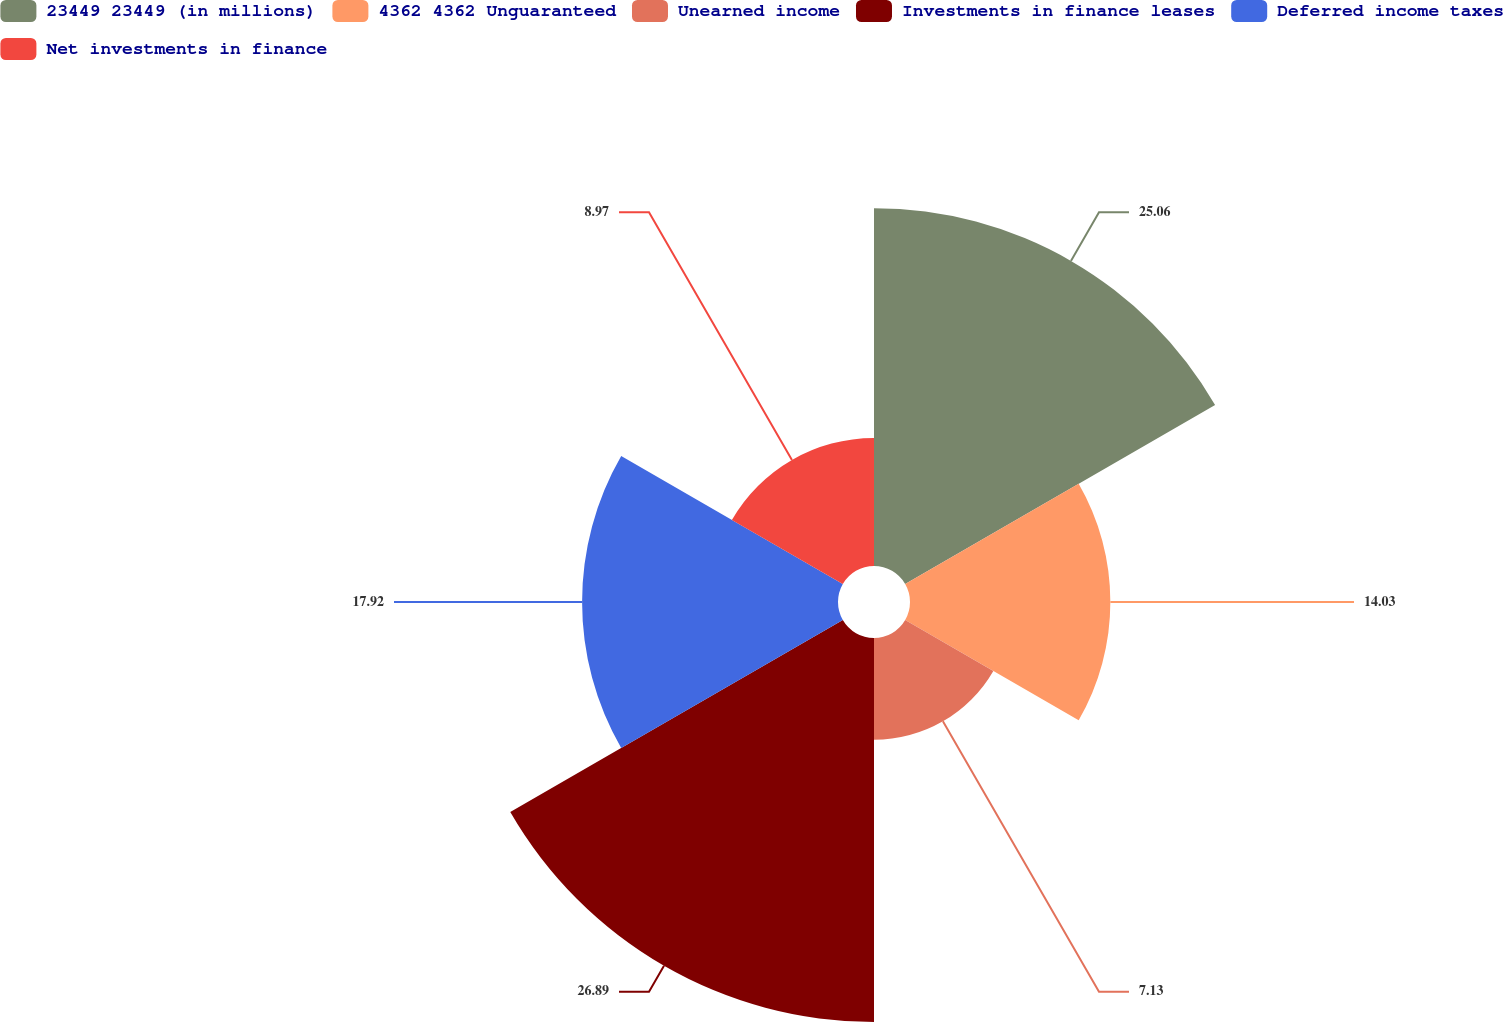Convert chart to OTSL. <chart><loc_0><loc_0><loc_500><loc_500><pie_chart><fcel>23449 23449 (in millions)<fcel>4362 4362 Unguaranteed<fcel>Unearned income<fcel>Investments in finance leases<fcel>Deferred income taxes<fcel>Net investments in finance<nl><fcel>25.06%<fcel>14.03%<fcel>7.13%<fcel>26.89%<fcel>17.92%<fcel>8.97%<nl></chart> 